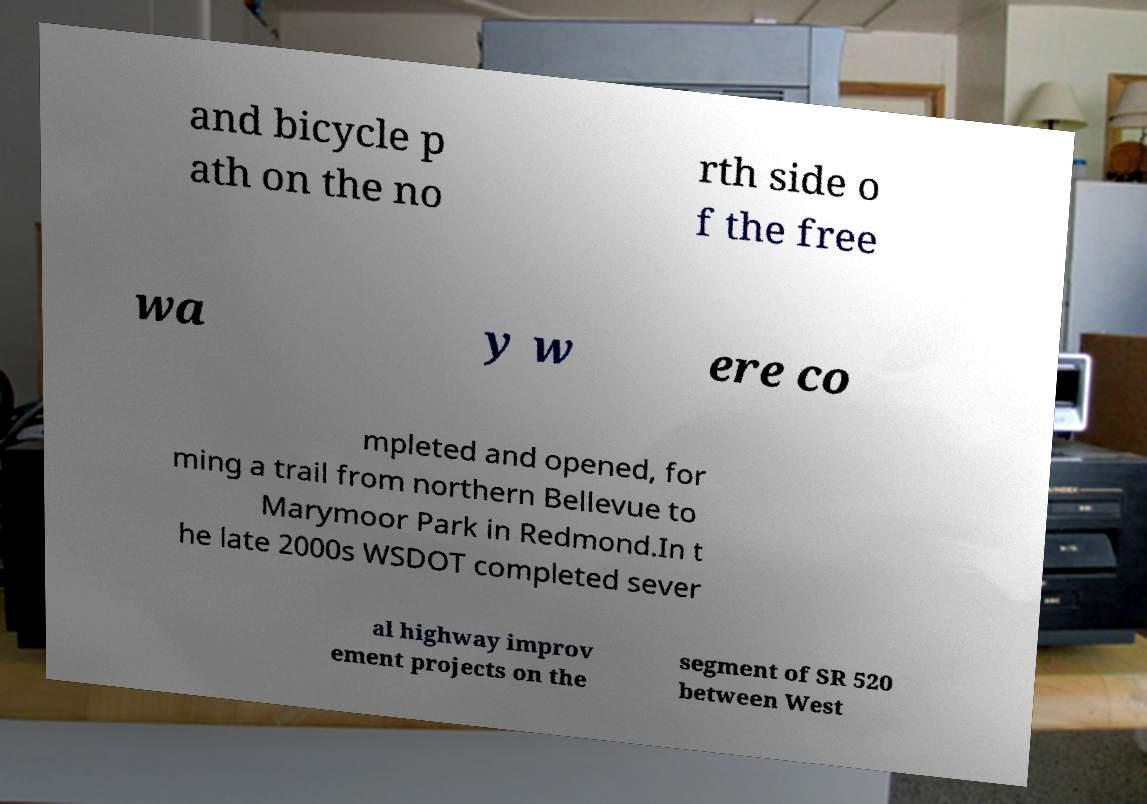Please identify and transcribe the text found in this image. and bicycle p ath on the no rth side o f the free wa y w ere co mpleted and opened, for ming a trail from northern Bellevue to Marymoor Park in Redmond.In t he late 2000s WSDOT completed sever al highway improv ement projects on the segment of SR 520 between West 